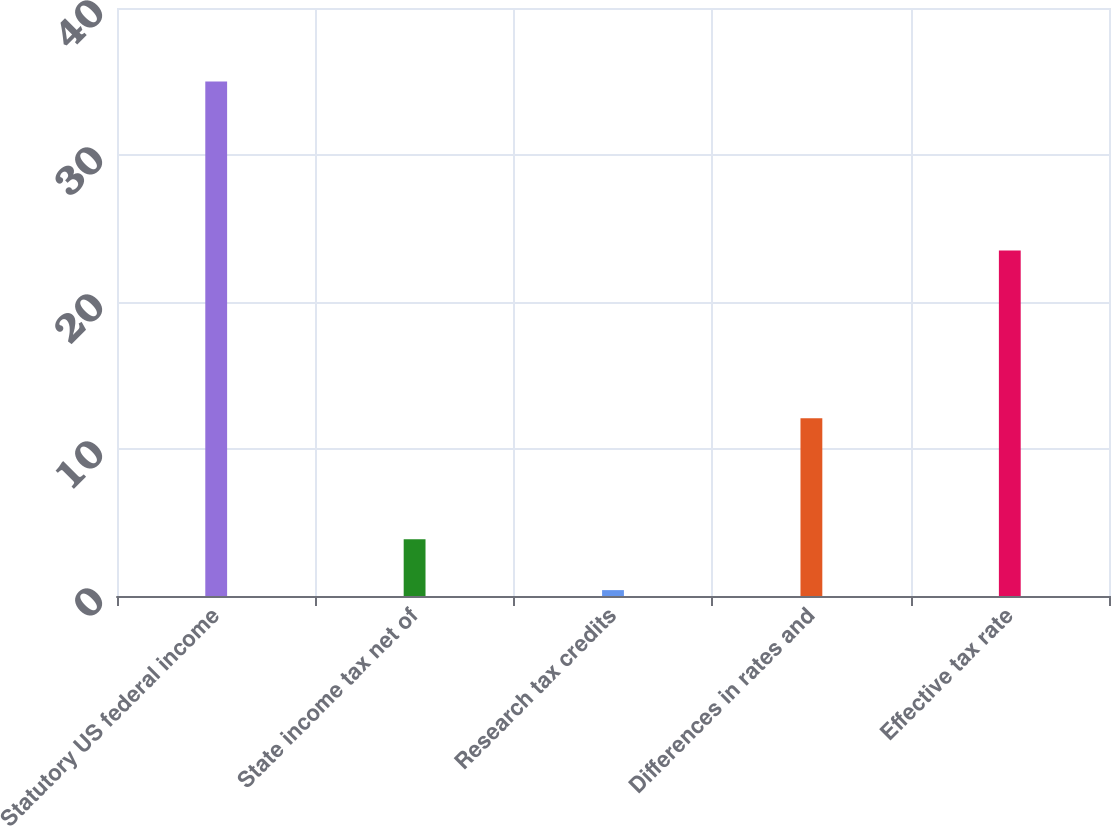Convert chart to OTSL. <chart><loc_0><loc_0><loc_500><loc_500><bar_chart><fcel>Statutory US federal income<fcel>State income tax net of<fcel>Research tax credits<fcel>Differences in rates and<fcel>Effective tax rate<nl><fcel>35<fcel>3.86<fcel>0.4<fcel>12.1<fcel>23.5<nl></chart> 